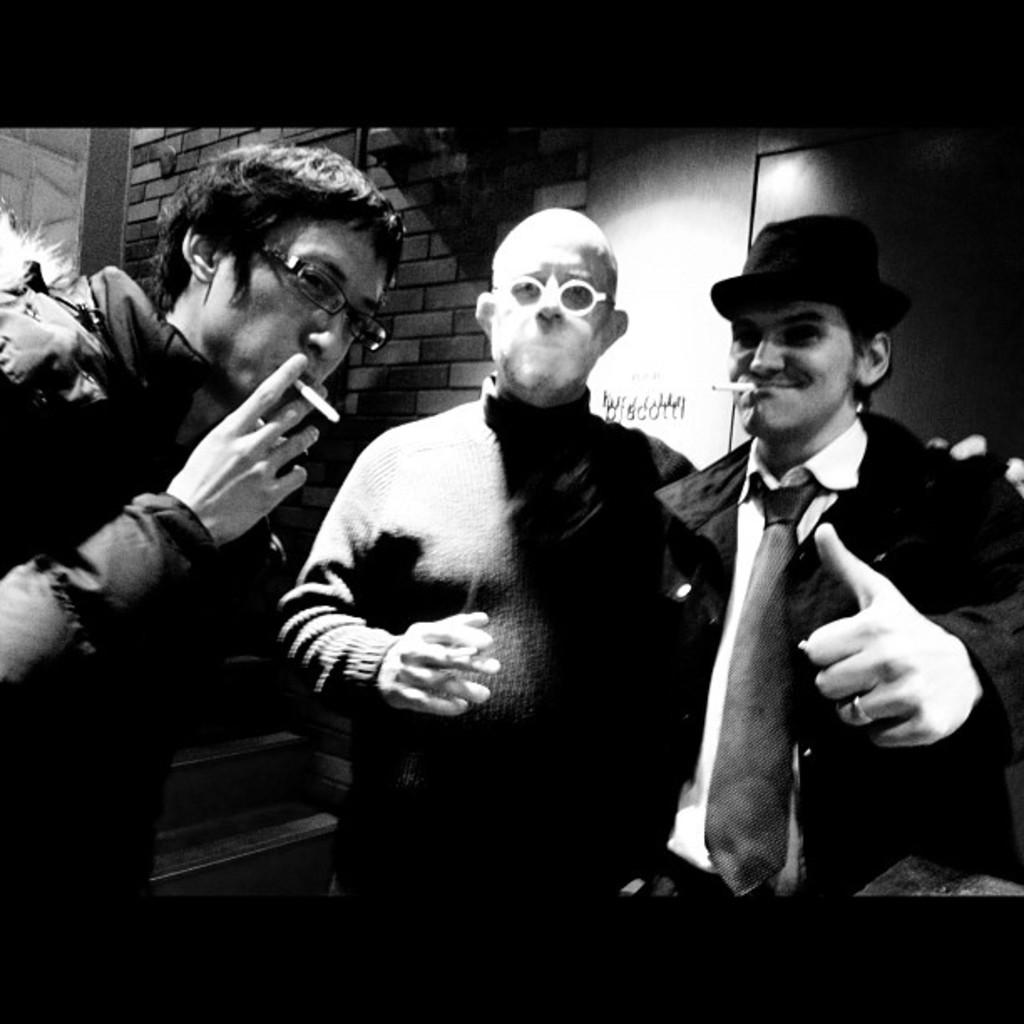How many people are in the image? There are three persons in the image. What are the persons doing in the image? The persons are smoking. What can be seen in the background of the image? There is a wall in the background of the image. What type of skirt is the banana wearing in the image? There is no banana or skirt present in the image. 